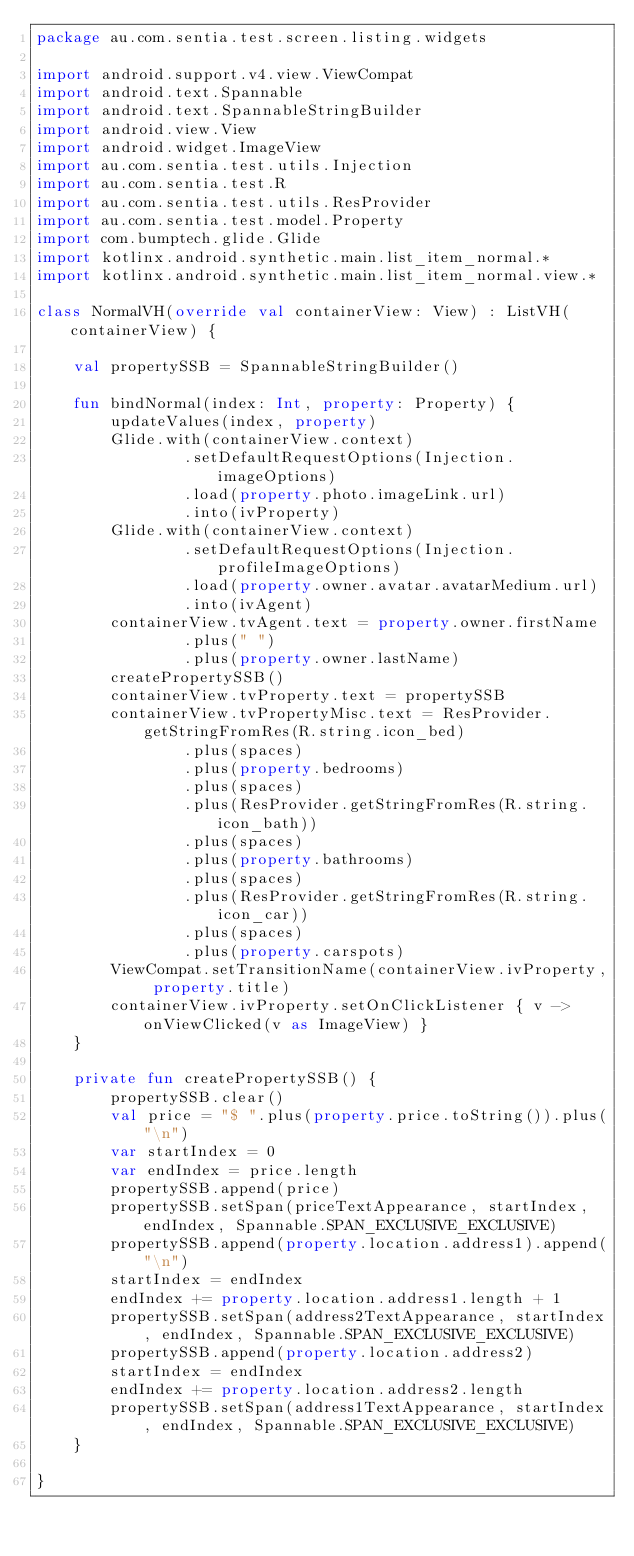Convert code to text. <code><loc_0><loc_0><loc_500><loc_500><_Kotlin_>package au.com.sentia.test.screen.listing.widgets

import android.support.v4.view.ViewCompat
import android.text.Spannable
import android.text.SpannableStringBuilder
import android.view.View
import android.widget.ImageView
import au.com.sentia.test.utils.Injection
import au.com.sentia.test.R
import au.com.sentia.test.utils.ResProvider
import au.com.sentia.test.model.Property
import com.bumptech.glide.Glide
import kotlinx.android.synthetic.main.list_item_normal.*
import kotlinx.android.synthetic.main.list_item_normal.view.*

class NormalVH(override val containerView: View) : ListVH(containerView) {

    val propertySSB = SpannableStringBuilder()

    fun bindNormal(index: Int, property: Property) {
        updateValues(index, property)
        Glide.with(containerView.context)
                .setDefaultRequestOptions(Injection.imageOptions)
                .load(property.photo.imageLink.url)
                .into(ivProperty)
        Glide.with(containerView.context)
                .setDefaultRequestOptions(Injection.profileImageOptions)
                .load(property.owner.avatar.avatarMedium.url)
                .into(ivAgent)
        containerView.tvAgent.text = property.owner.firstName
                .plus(" ")
                .plus(property.owner.lastName)
        createPropertySSB()
        containerView.tvProperty.text = propertySSB
        containerView.tvPropertyMisc.text = ResProvider.getStringFromRes(R.string.icon_bed)
                .plus(spaces)
                .plus(property.bedrooms)
                .plus(spaces)
                .plus(ResProvider.getStringFromRes(R.string.icon_bath))
                .plus(spaces)
                .plus(property.bathrooms)
                .plus(spaces)
                .plus(ResProvider.getStringFromRes(R.string.icon_car))
                .plus(spaces)
                .plus(property.carspots)
        ViewCompat.setTransitionName(containerView.ivProperty, property.title)
        containerView.ivProperty.setOnClickListener { v -> onViewClicked(v as ImageView) }
    }

    private fun createPropertySSB() {
        propertySSB.clear()
        val price = "$ ".plus(property.price.toString()).plus("\n")
        var startIndex = 0
        var endIndex = price.length
        propertySSB.append(price)
        propertySSB.setSpan(priceTextAppearance, startIndex, endIndex, Spannable.SPAN_EXCLUSIVE_EXCLUSIVE)
        propertySSB.append(property.location.address1).append("\n")
        startIndex = endIndex
        endIndex += property.location.address1.length + 1
        propertySSB.setSpan(address2TextAppearance, startIndex, endIndex, Spannable.SPAN_EXCLUSIVE_EXCLUSIVE)
        propertySSB.append(property.location.address2)
        startIndex = endIndex
        endIndex += property.location.address2.length
        propertySSB.setSpan(address1TextAppearance, startIndex, endIndex, Spannable.SPAN_EXCLUSIVE_EXCLUSIVE)
    }

}
</code> 